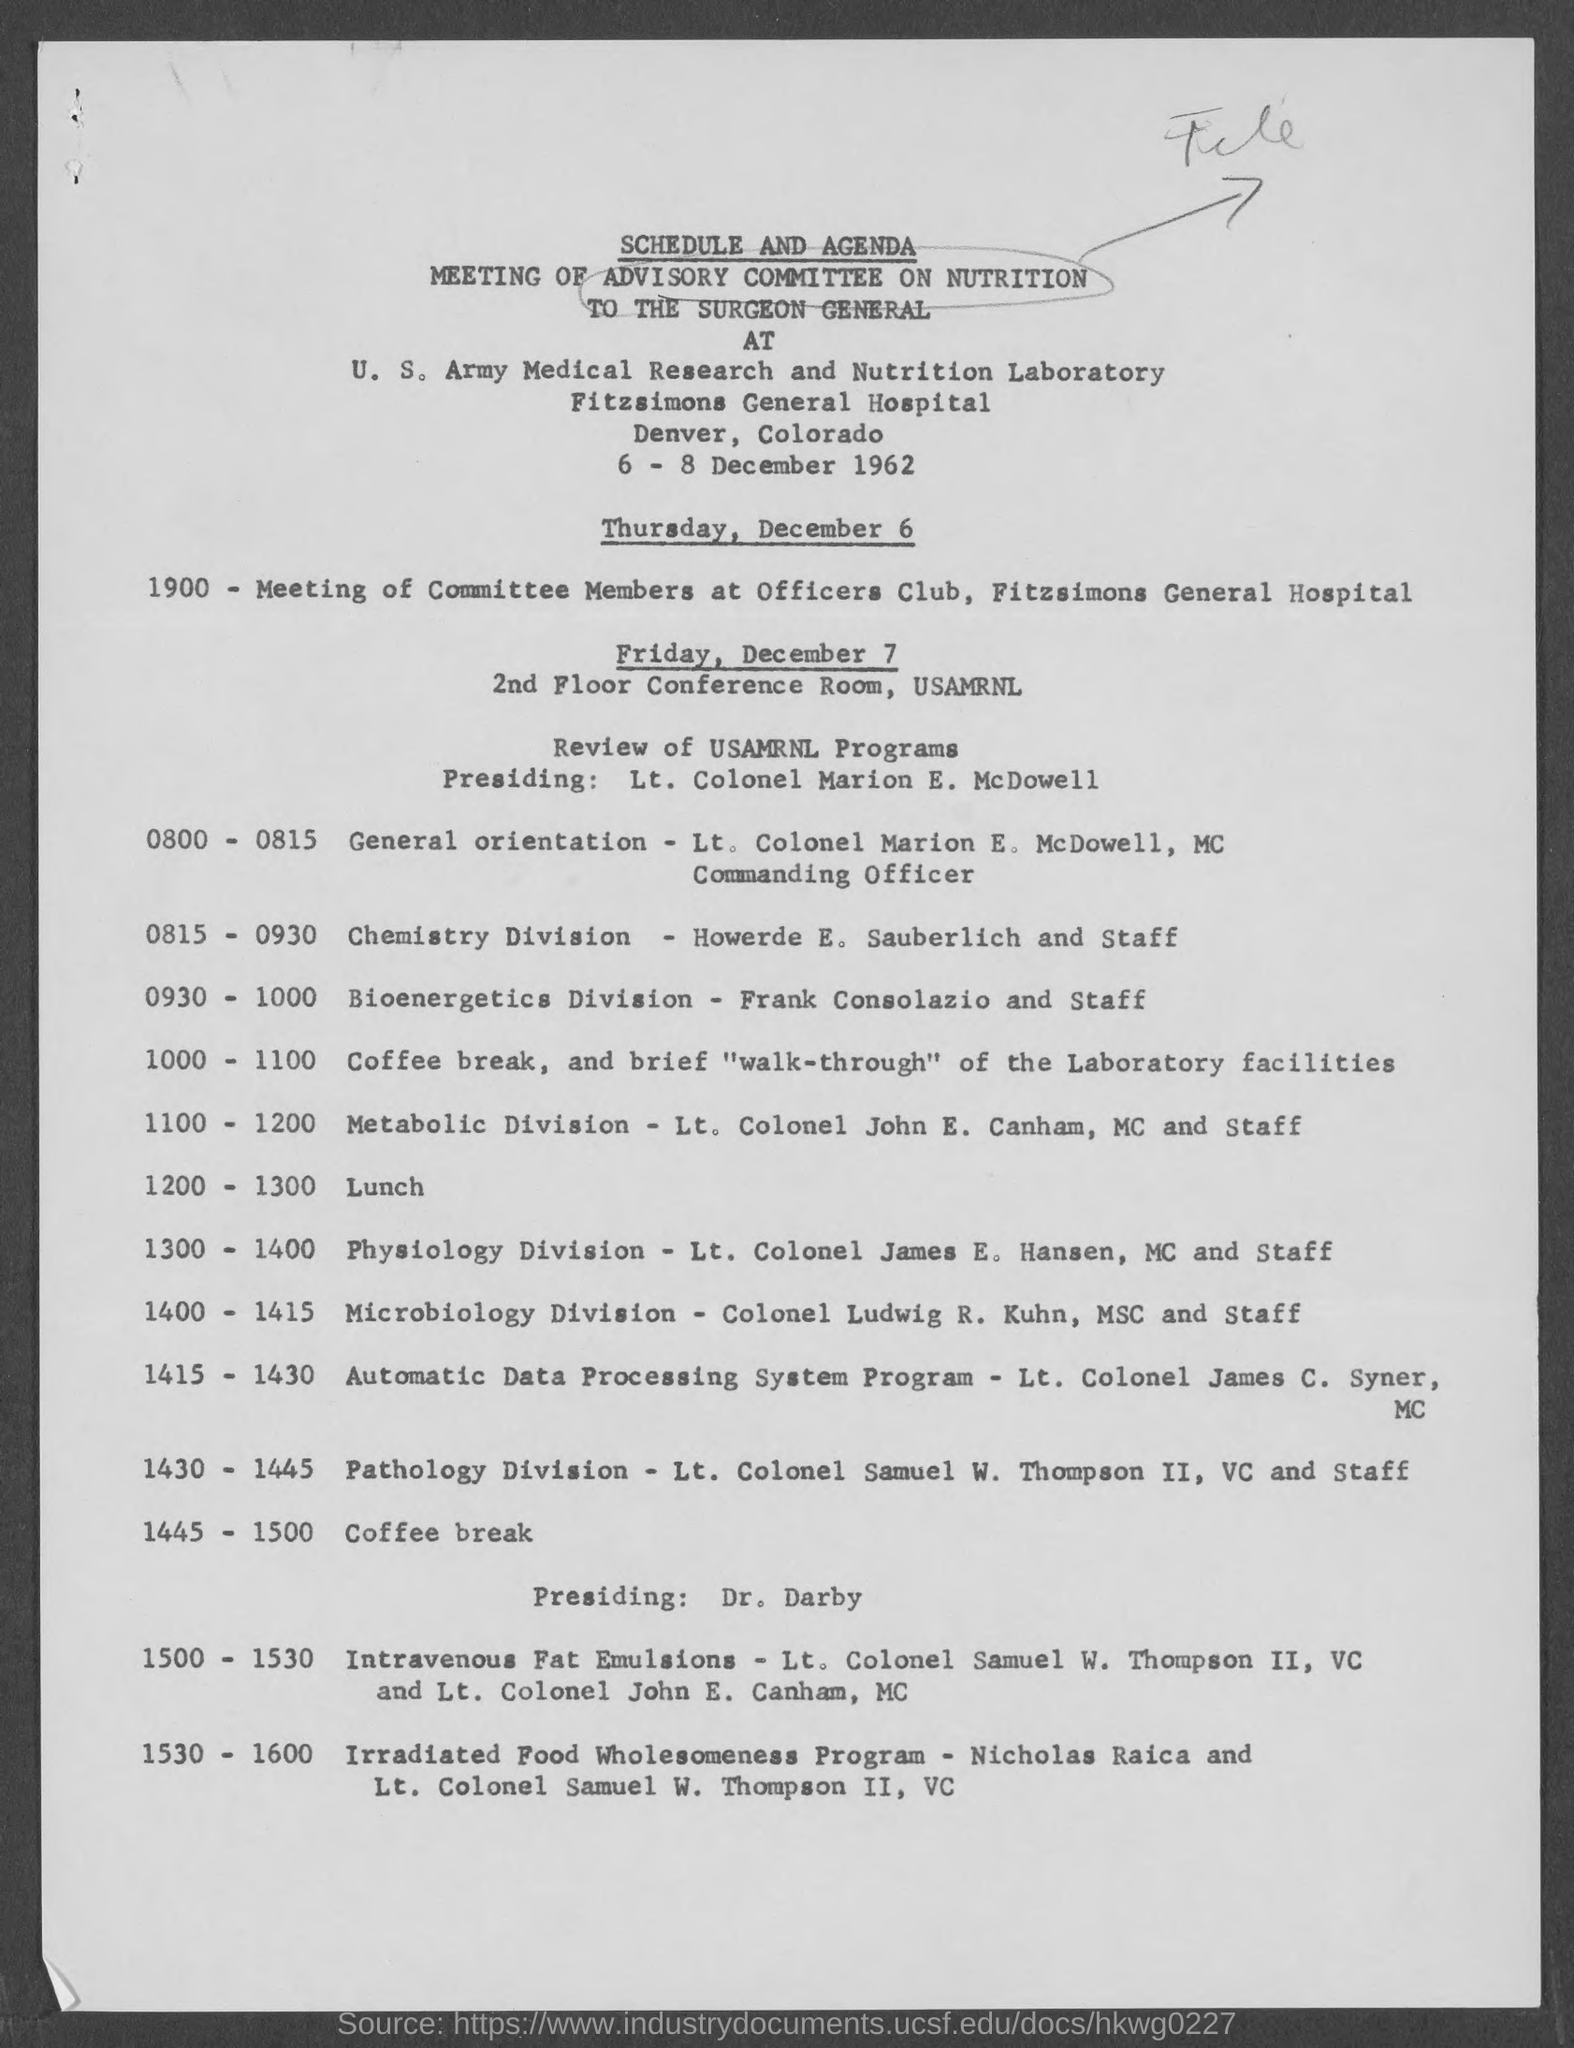Outline some significant characteristics in this image. At the time of 1445 - 1500, there will be a coffee break. At the time of 1300 - 1400, the scheduled division is physiology. At the time of 1000 - 1100, a coffee break and a brief walk-through of the laboratory facilities will be scheduled. The Fitzsimons General Hospital is the name of the hospital mentioned on the given page. At the time of 1200 - 1300, lunch is scheduled. 